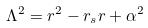Convert formula to latex. <formula><loc_0><loc_0><loc_500><loc_500>\Lambda ^ { 2 } = r ^ { 2 } - r _ { s } r + \alpha ^ { 2 }</formula> 